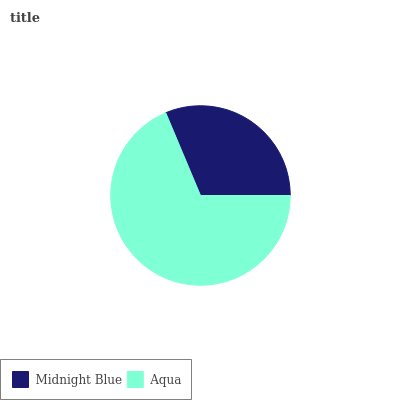Is Midnight Blue the minimum?
Answer yes or no. Yes. Is Aqua the maximum?
Answer yes or no. Yes. Is Aqua the minimum?
Answer yes or no. No. Is Aqua greater than Midnight Blue?
Answer yes or no. Yes. Is Midnight Blue less than Aqua?
Answer yes or no. Yes. Is Midnight Blue greater than Aqua?
Answer yes or no. No. Is Aqua less than Midnight Blue?
Answer yes or no. No. Is Aqua the high median?
Answer yes or no. Yes. Is Midnight Blue the low median?
Answer yes or no. Yes. Is Midnight Blue the high median?
Answer yes or no. No. Is Aqua the low median?
Answer yes or no. No. 